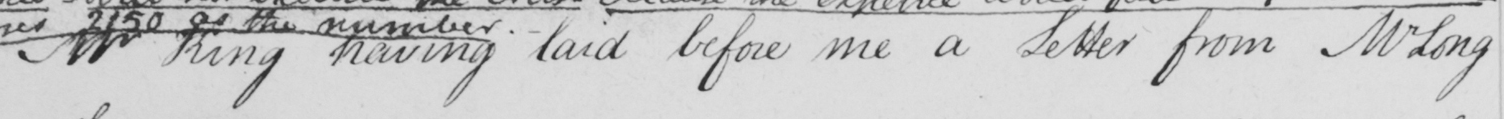Please transcribe the handwritten text in this image. Mr King having laid before me a Letter from Mr Long 